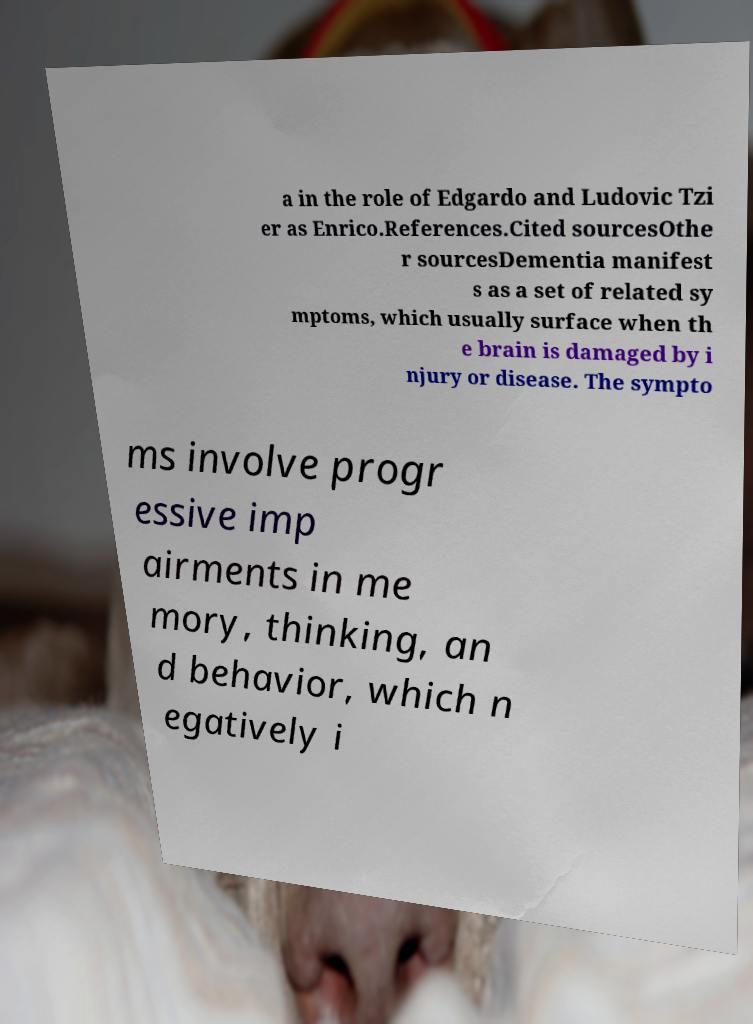Can you read and provide the text displayed in the image?This photo seems to have some interesting text. Can you extract and type it out for me? a in the role of Edgardo and Ludovic Tzi er as Enrico.References.Cited sourcesOthe r sourcesDementia manifest s as a set of related sy mptoms, which usually surface when th e brain is damaged by i njury or disease. The sympto ms involve progr essive imp airments in me mory, thinking, an d behavior, which n egatively i 